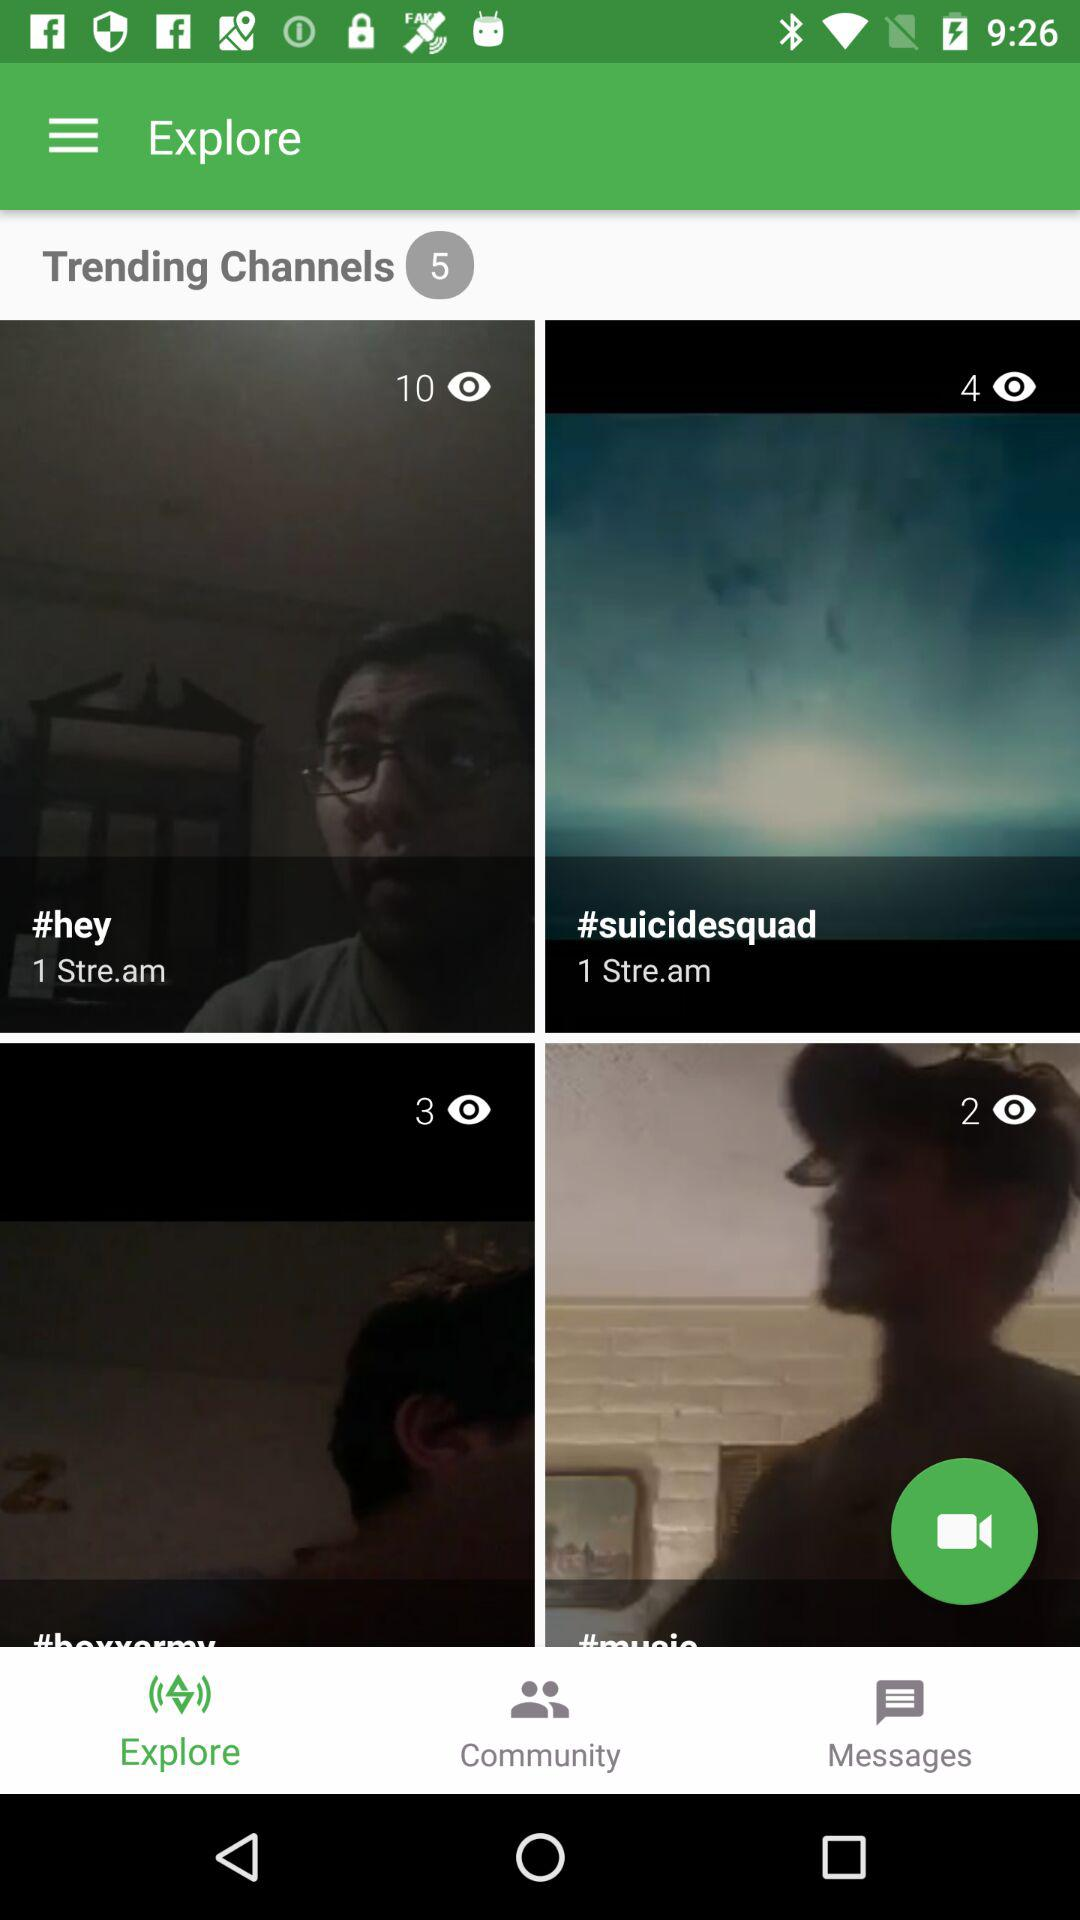Which stream has 10 views? The stream is "#hey". 